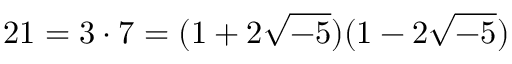<formula> <loc_0><loc_0><loc_500><loc_500>2 1 = 3 \cdot 7 = ( 1 + 2 { \sqrt { - 5 } } ) ( 1 - 2 { \sqrt { - 5 } } )</formula> 